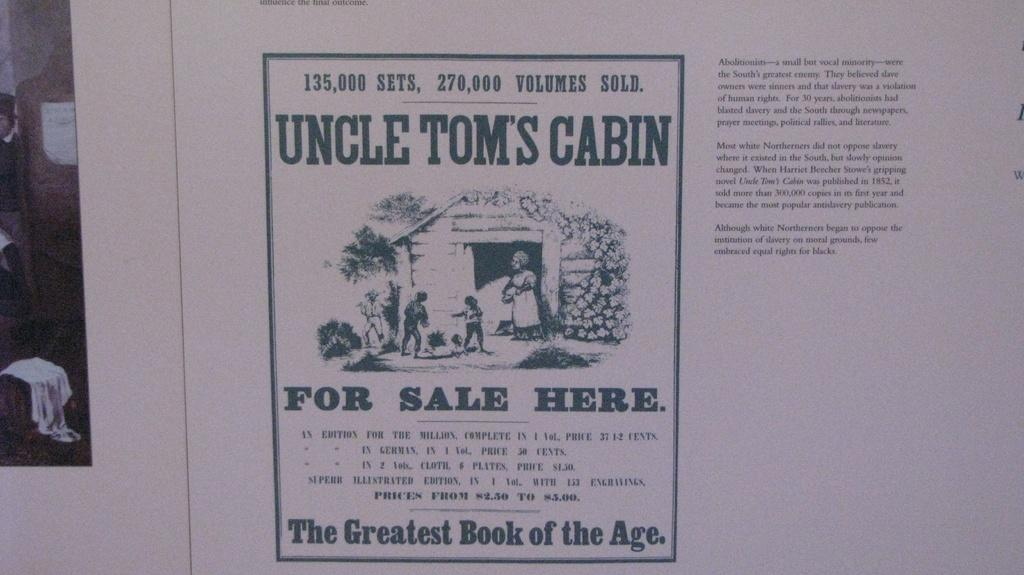What can be seen in the image? There are images of people in the image. What else is present in the image besides the images of people? There is text present in the image. What type of quartz can be seen in the image? There is no quartz present in the image. Are there any gloves visible in the image? There are no gloves visible in the image. 